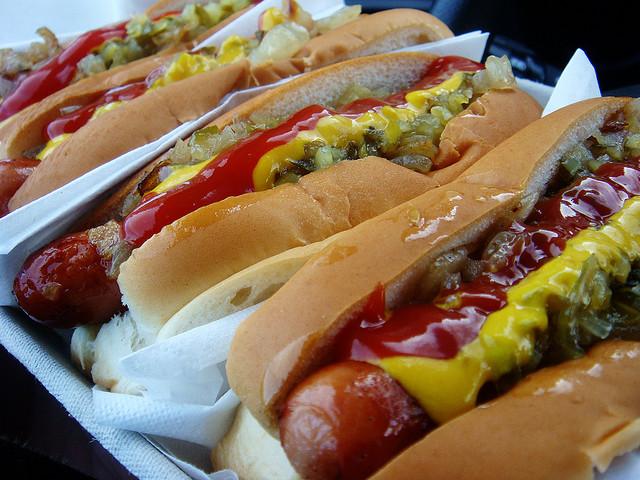How many hot dogs are visible?
Be succinct. 4. What is the red condiment on the hot dogs?
Keep it brief. Ketchup. Is there mustard?
Keep it brief. Yes. 